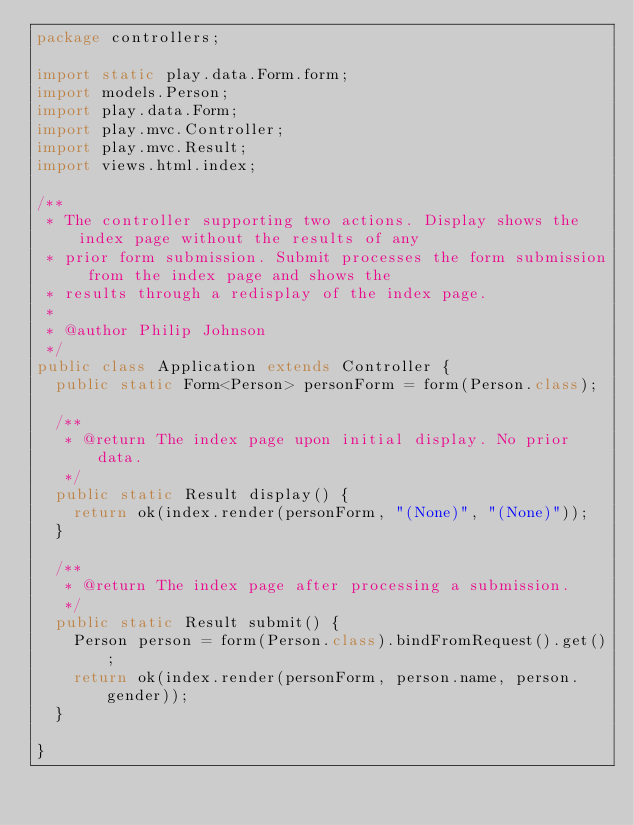<code> <loc_0><loc_0><loc_500><loc_500><_Java_>package controllers;

import static play.data.Form.form;
import models.Person;
import play.data.Form;
import play.mvc.Controller;
import play.mvc.Result;
import views.html.index;

/**
 * The controller supporting two actions. Display shows the index page without the results of any
 * prior form submission. Submit processes the form submission from the index page and shows the
 * results through a redisplay of the index page.
 * 
 * @author Philip Johnson
 */
public class Application extends Controller {
  public static Form<Person> personForm = form(Person.class);

  /**
   * @return The index page upon initial display. No prior data.
   */
  public static Result display() {
    return ok(index.render(personForm, "(None)", "(None)"));
  }

  /**
   * @return The index page after processing a submission.
   */
  public static Result submit() {
    Person person = form(Person.class).bindFromRequest().get();
    return ok(index.render(personForm, person.name, person.gender));
  }

}
</code> 